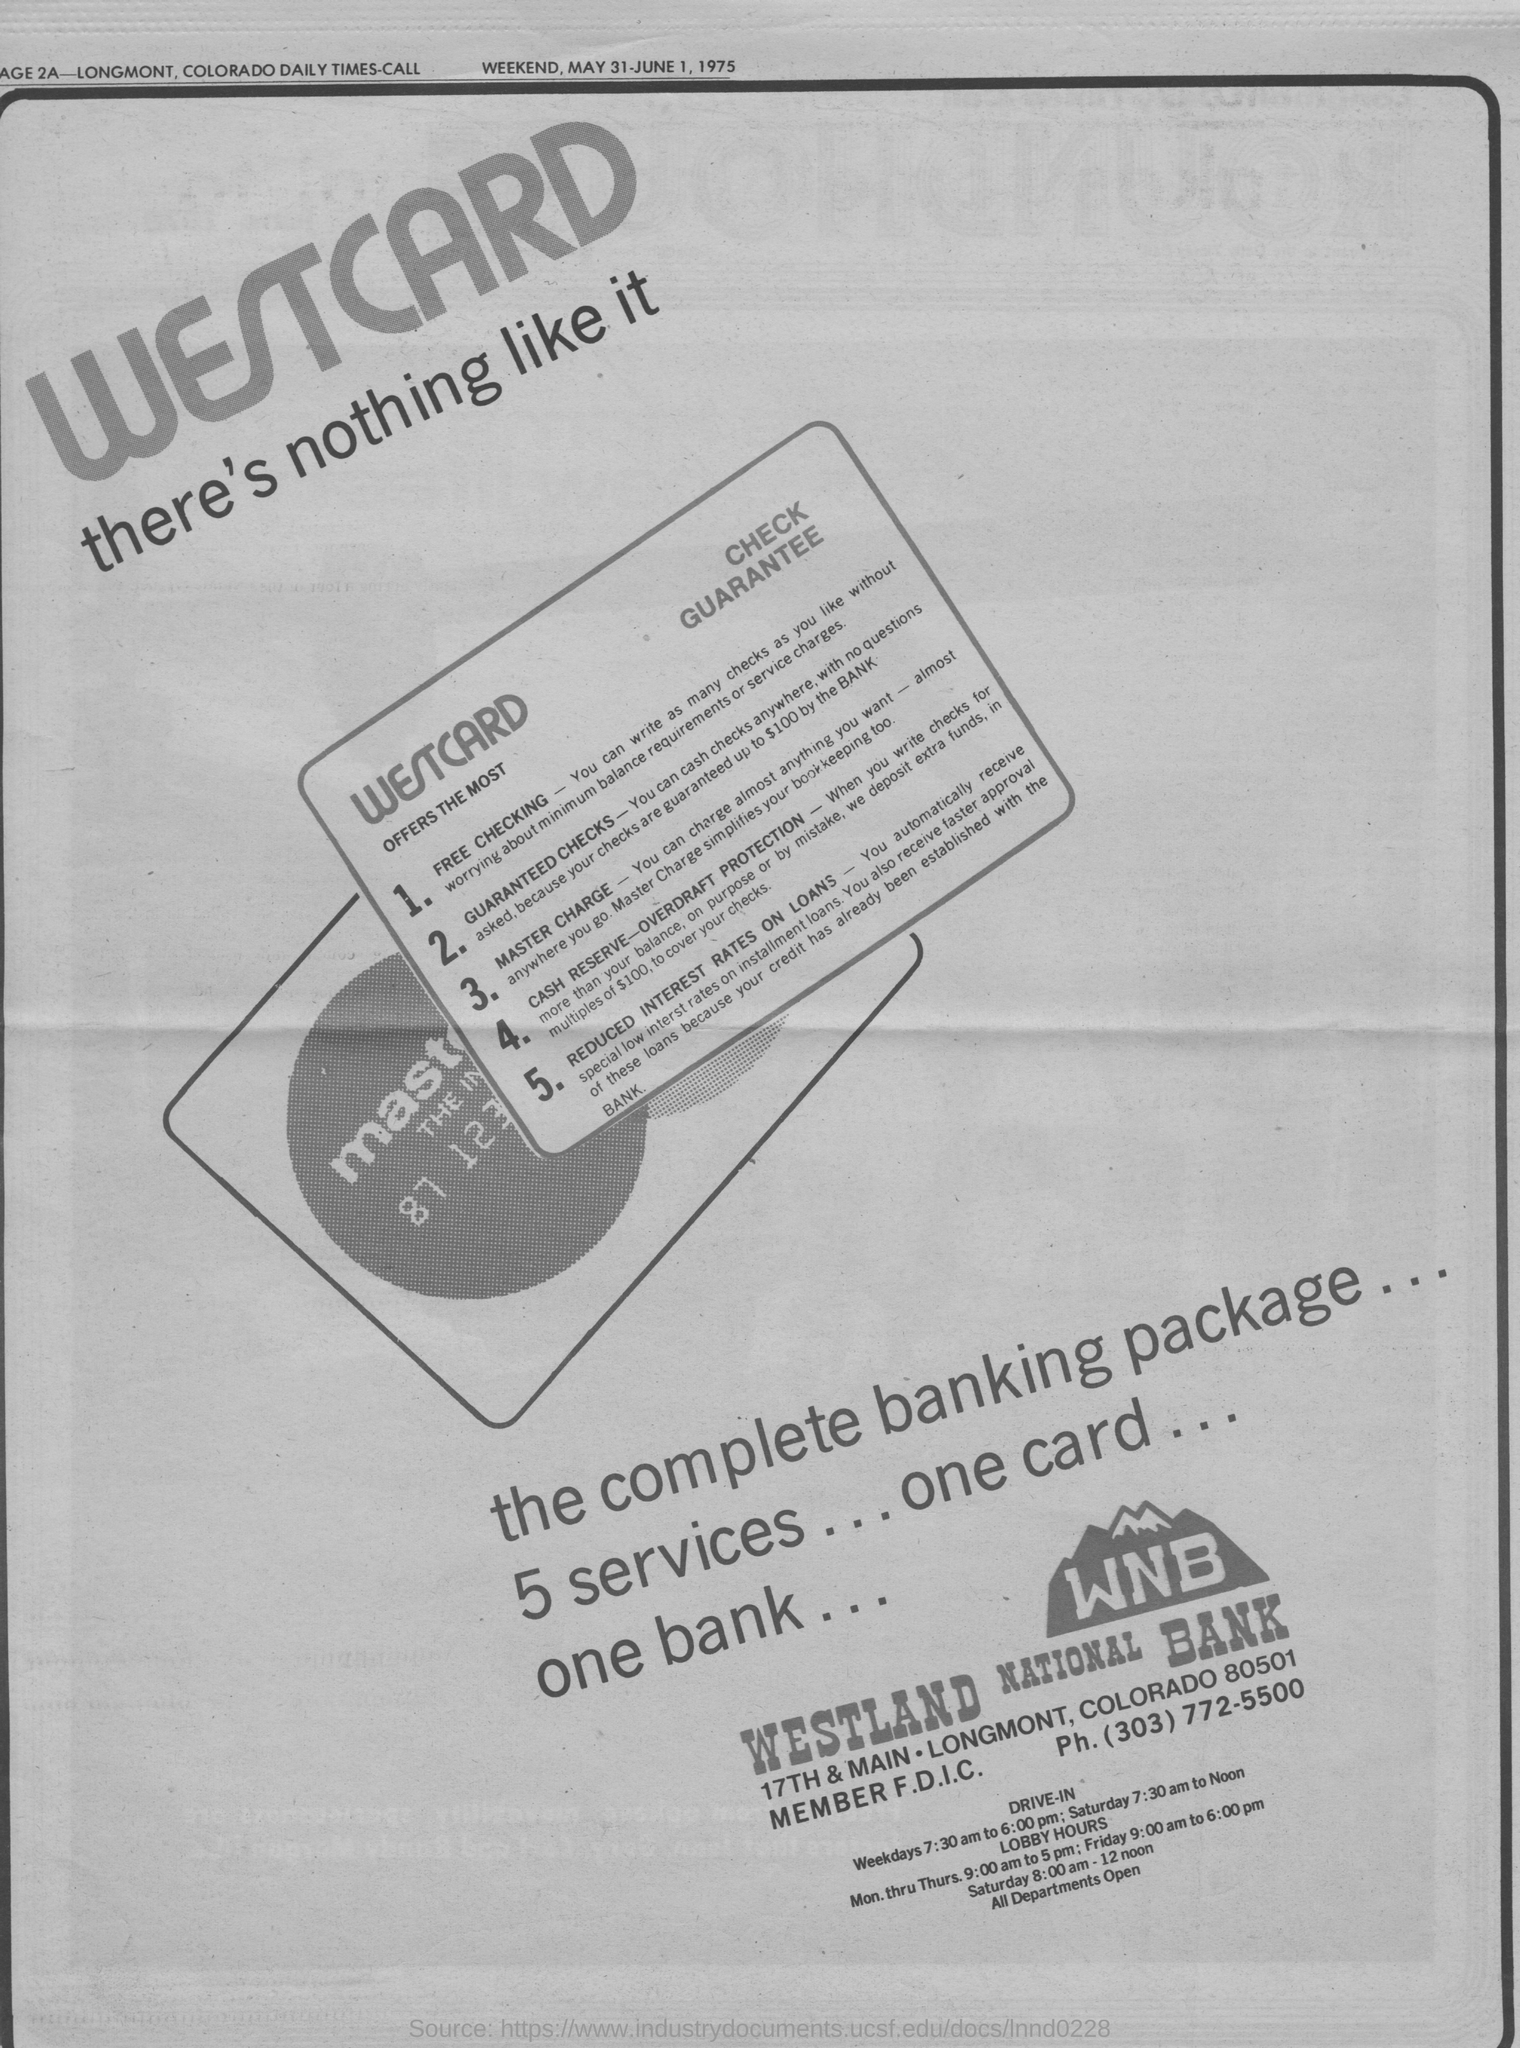Outline some significant characteristics in this image. The advertisement is from a bank whose name begins with the letters "WNB. This article was printed on the weekend of May 31-June 1, 1975. 